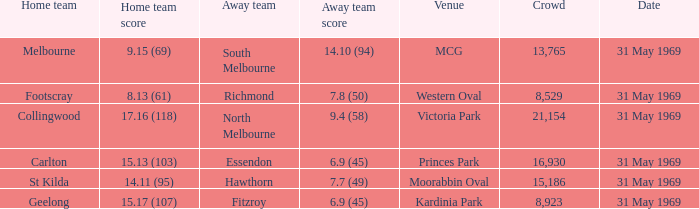Which hosting team had a score of 14.11 (95)? St Kilda. 